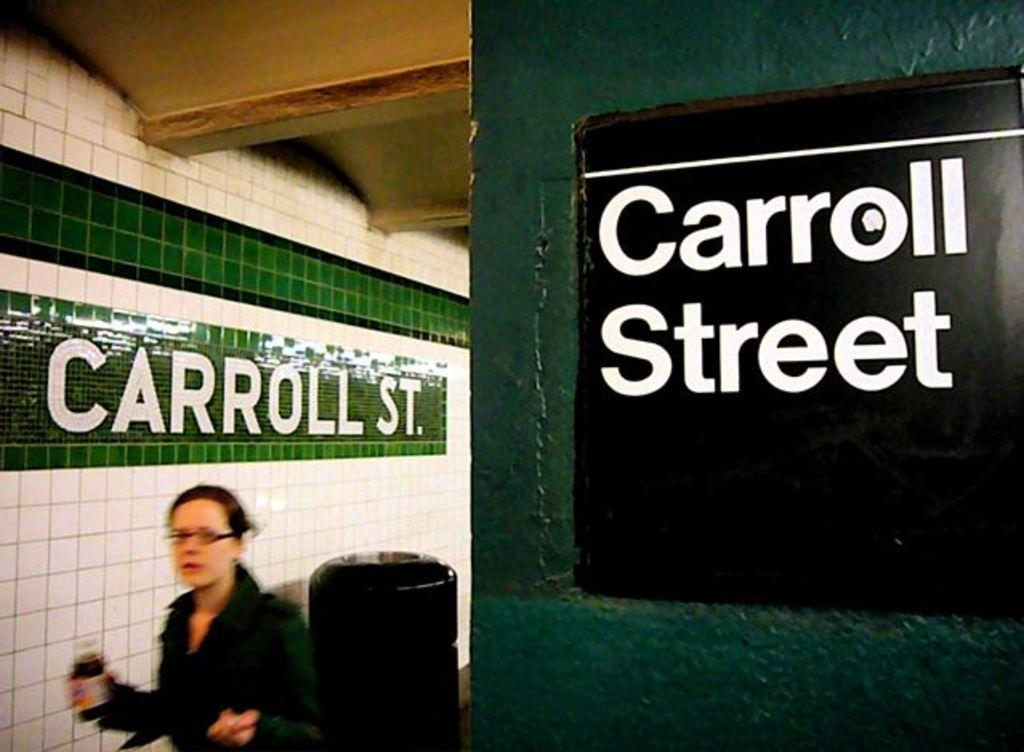Who is present in the image? There is a woman in the image. What is the woman holding in her hands? The woman is holding an object in her hands. What can be seen on the walls in the image? There are walls with text visible in the image. What type of cannon is visible in the image? There is no cannon present in the image. What color is the sky in the image? The provided facts do not mention the sky, so we cannot determine its color from the image. 